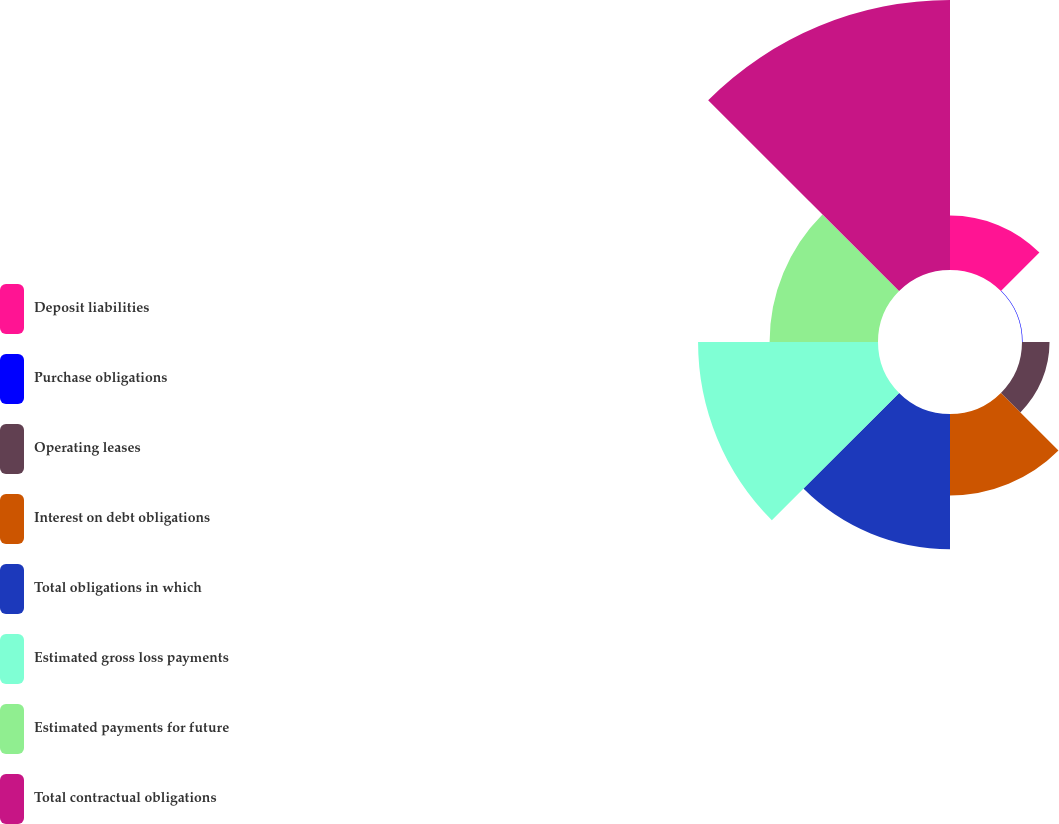Convert chart to OTSL. <chart><loc_0><loc_0><loc_500><loc_500><pie_chart><fcel>Deposit liabilities<fcel>Purchase obligations<fcel>Operating leases<fcel>Interest on debt obligations<fcel>Total obligations in which<fcel>Estimated gross loss payments<fcel>Estimated payments for future<fcel>Total contractual obligations<nl><fcel>6.35%<fcel>0.07%<fcel>3.21%<fcel>9.49%<fcel>15.78%<fcel>20.98%<fcel>12.64%<fcel>31.48%<nl></chart> 